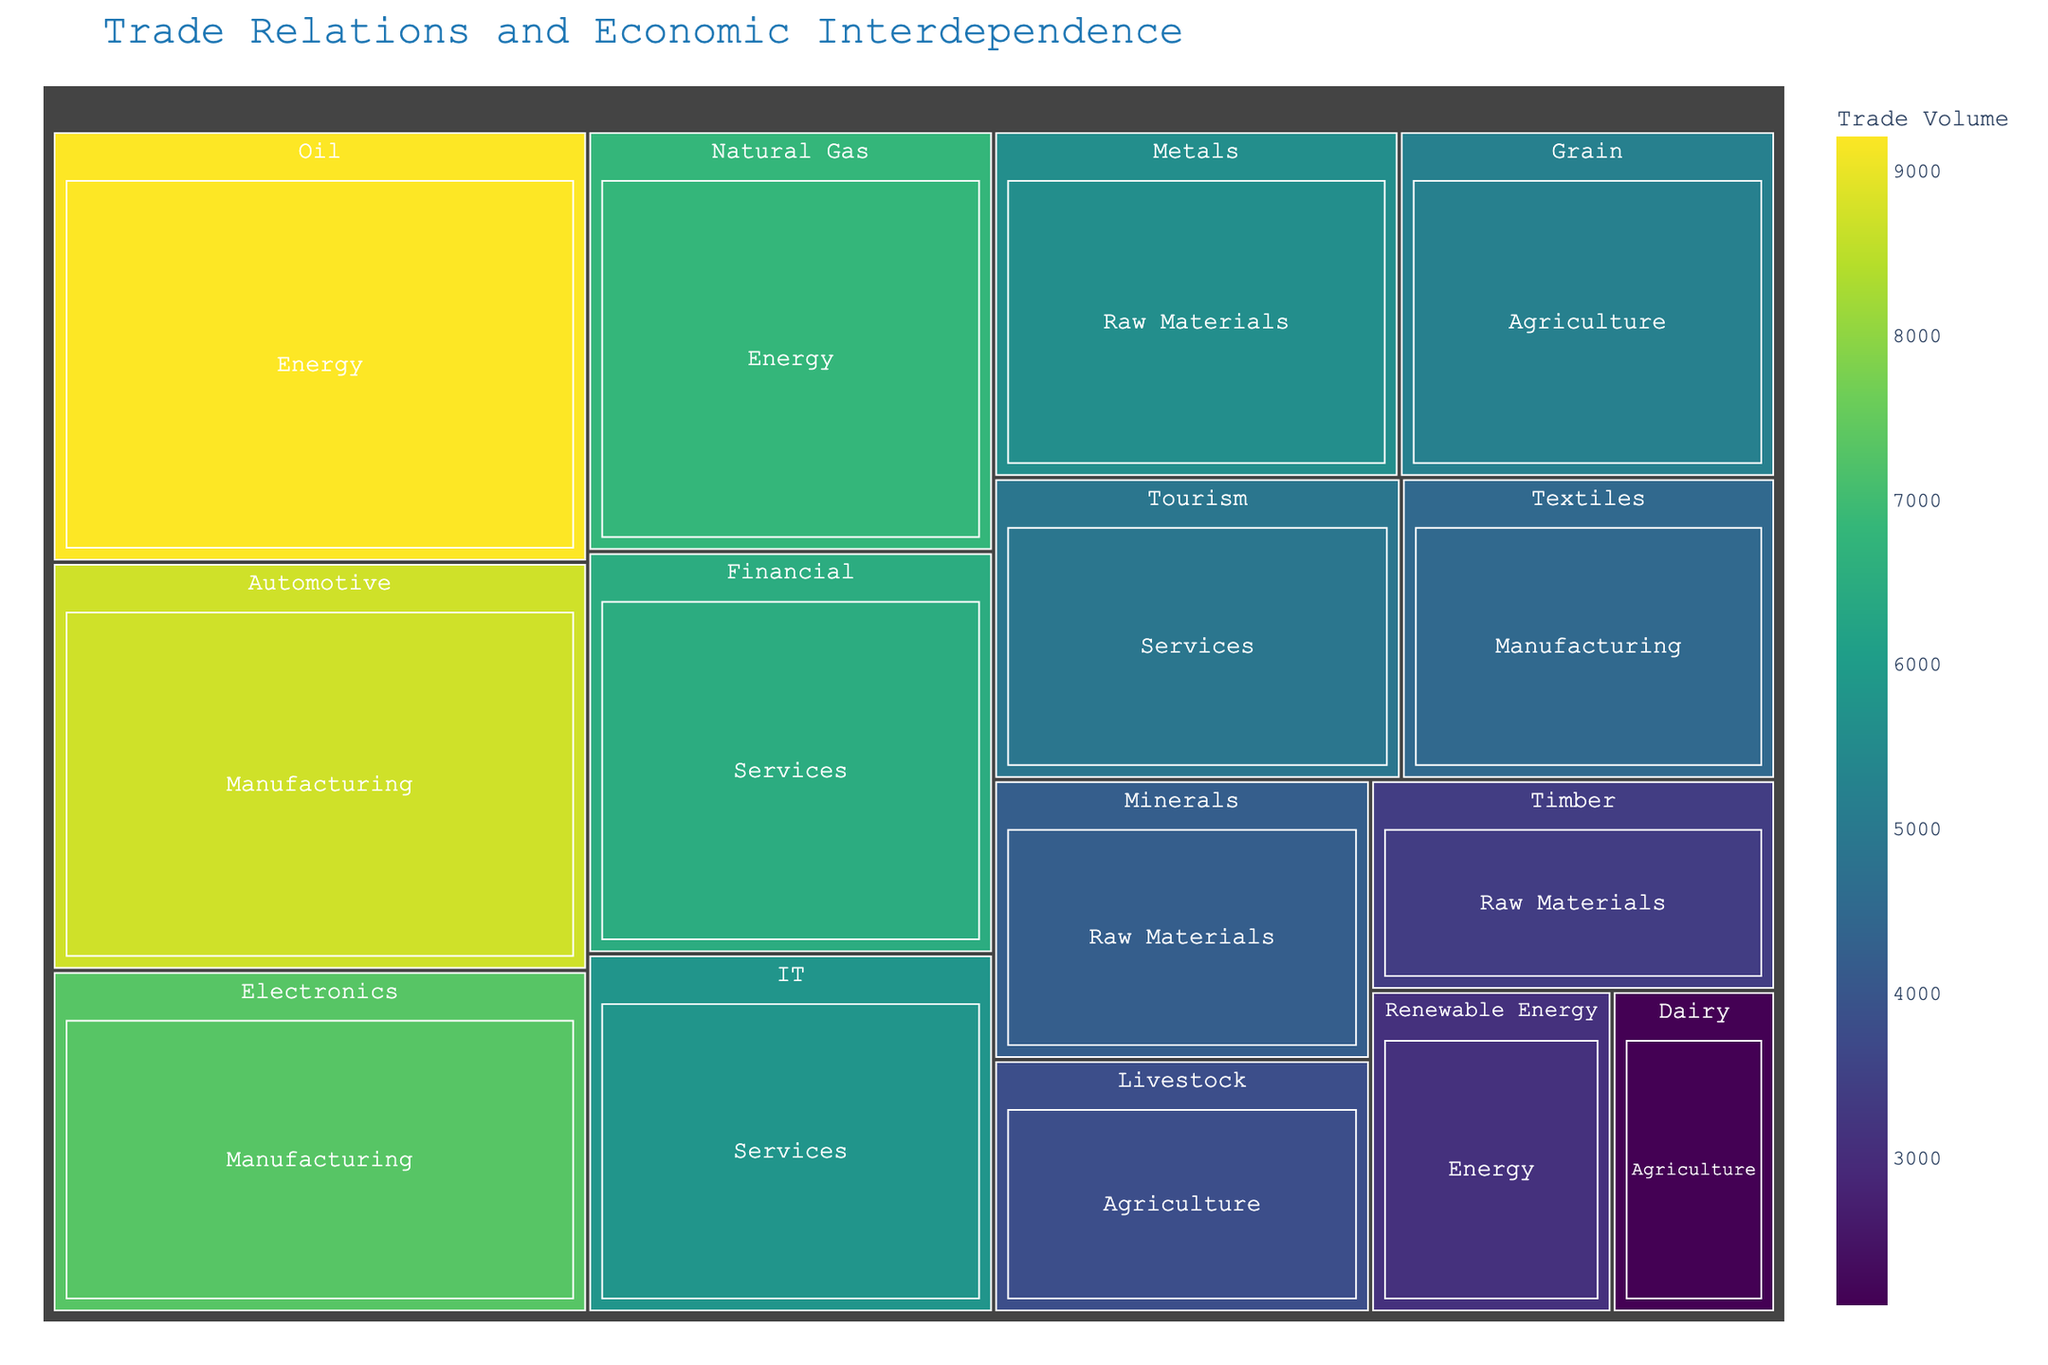How many sectors are shown in the Treemap? The Treemap is segmented by sectors. By visually counting the distinct categories in the Treemap, we can identify the number of sectors.
Answer: 5 Which sector has the highest trade volume? By observing the size and color intensity in the Treemap, the sector with the largest area and darkest color indicates the highest trade volume.
Answer: Energy Within the Services sector, which industry has the lowest trade volume? By examining the Treemap's Services sector, we can compare the areas of the Financial, Tourism, and IT industries. The smallest area represents the lowest trade volume.
Answer: Tourism What is the combined trade volume of the Agriculture and Raw Materials sectors? To find the combined trade volume, sum the trade volume of each industry in both sectors. Agriculture: 5200 (Grain) + 3800 (Livestock) + 2100 (Dairy) = 11100. Raw Materials: 3400 (Timber) + 4200 (Minerals) + 5600 (Metals) = 13200. Combined: 11100 + 13200 = 24300.
Answer: 24300 Which industry has the highest trade volume in the Manufacturing sector? By examining the Manufacturing sector in the Treemap, compare the trade volumes of Automotive, Electronics, and Textiles. The industry with the largest area represents the highest trade volume.
Answer: Automotive How does the trade volume of IT in Services compare to that of Textiles in Manufacturing? Locate the IT industry in the Services sector and Textiles in the Manufacturing sector. By comparing their areas and color intensities, determine which has a higher trade volume. IT sector's trade volume is 5800, and Textiles is 4500.
Answer: IT has a higher trade volume Calculate the average trade volume of the Energy sector's industries. To find the average, sum the trade volumes of the Oil, Natural Gas, and Renewable Energy industries and divide by the number of industries. (9200 + 6800 + 3100) / 3 = 19000 / 3.
Answer: 6333.33 What is the difference in trade volume between the Electronics industry in Manufacturing and the Financial industry in Services? Subtract the trade volume of the Financial industry in Services (6500) from the Electronics industry in Manufacturing (7300). 7300 - 6500 = 800.
Answer: 800 Which sector has the lowest total trade volume, and what is that volume? Sum the trade volumes for each sector and compare the totals. The sector with the smallest sum is the one we are interested in. Agriculture: 11100, Manufacturing: 20500, Energy: 19100, Services: 17200, Raw Materials: 13200.
Answer: Agriculture, 11100 